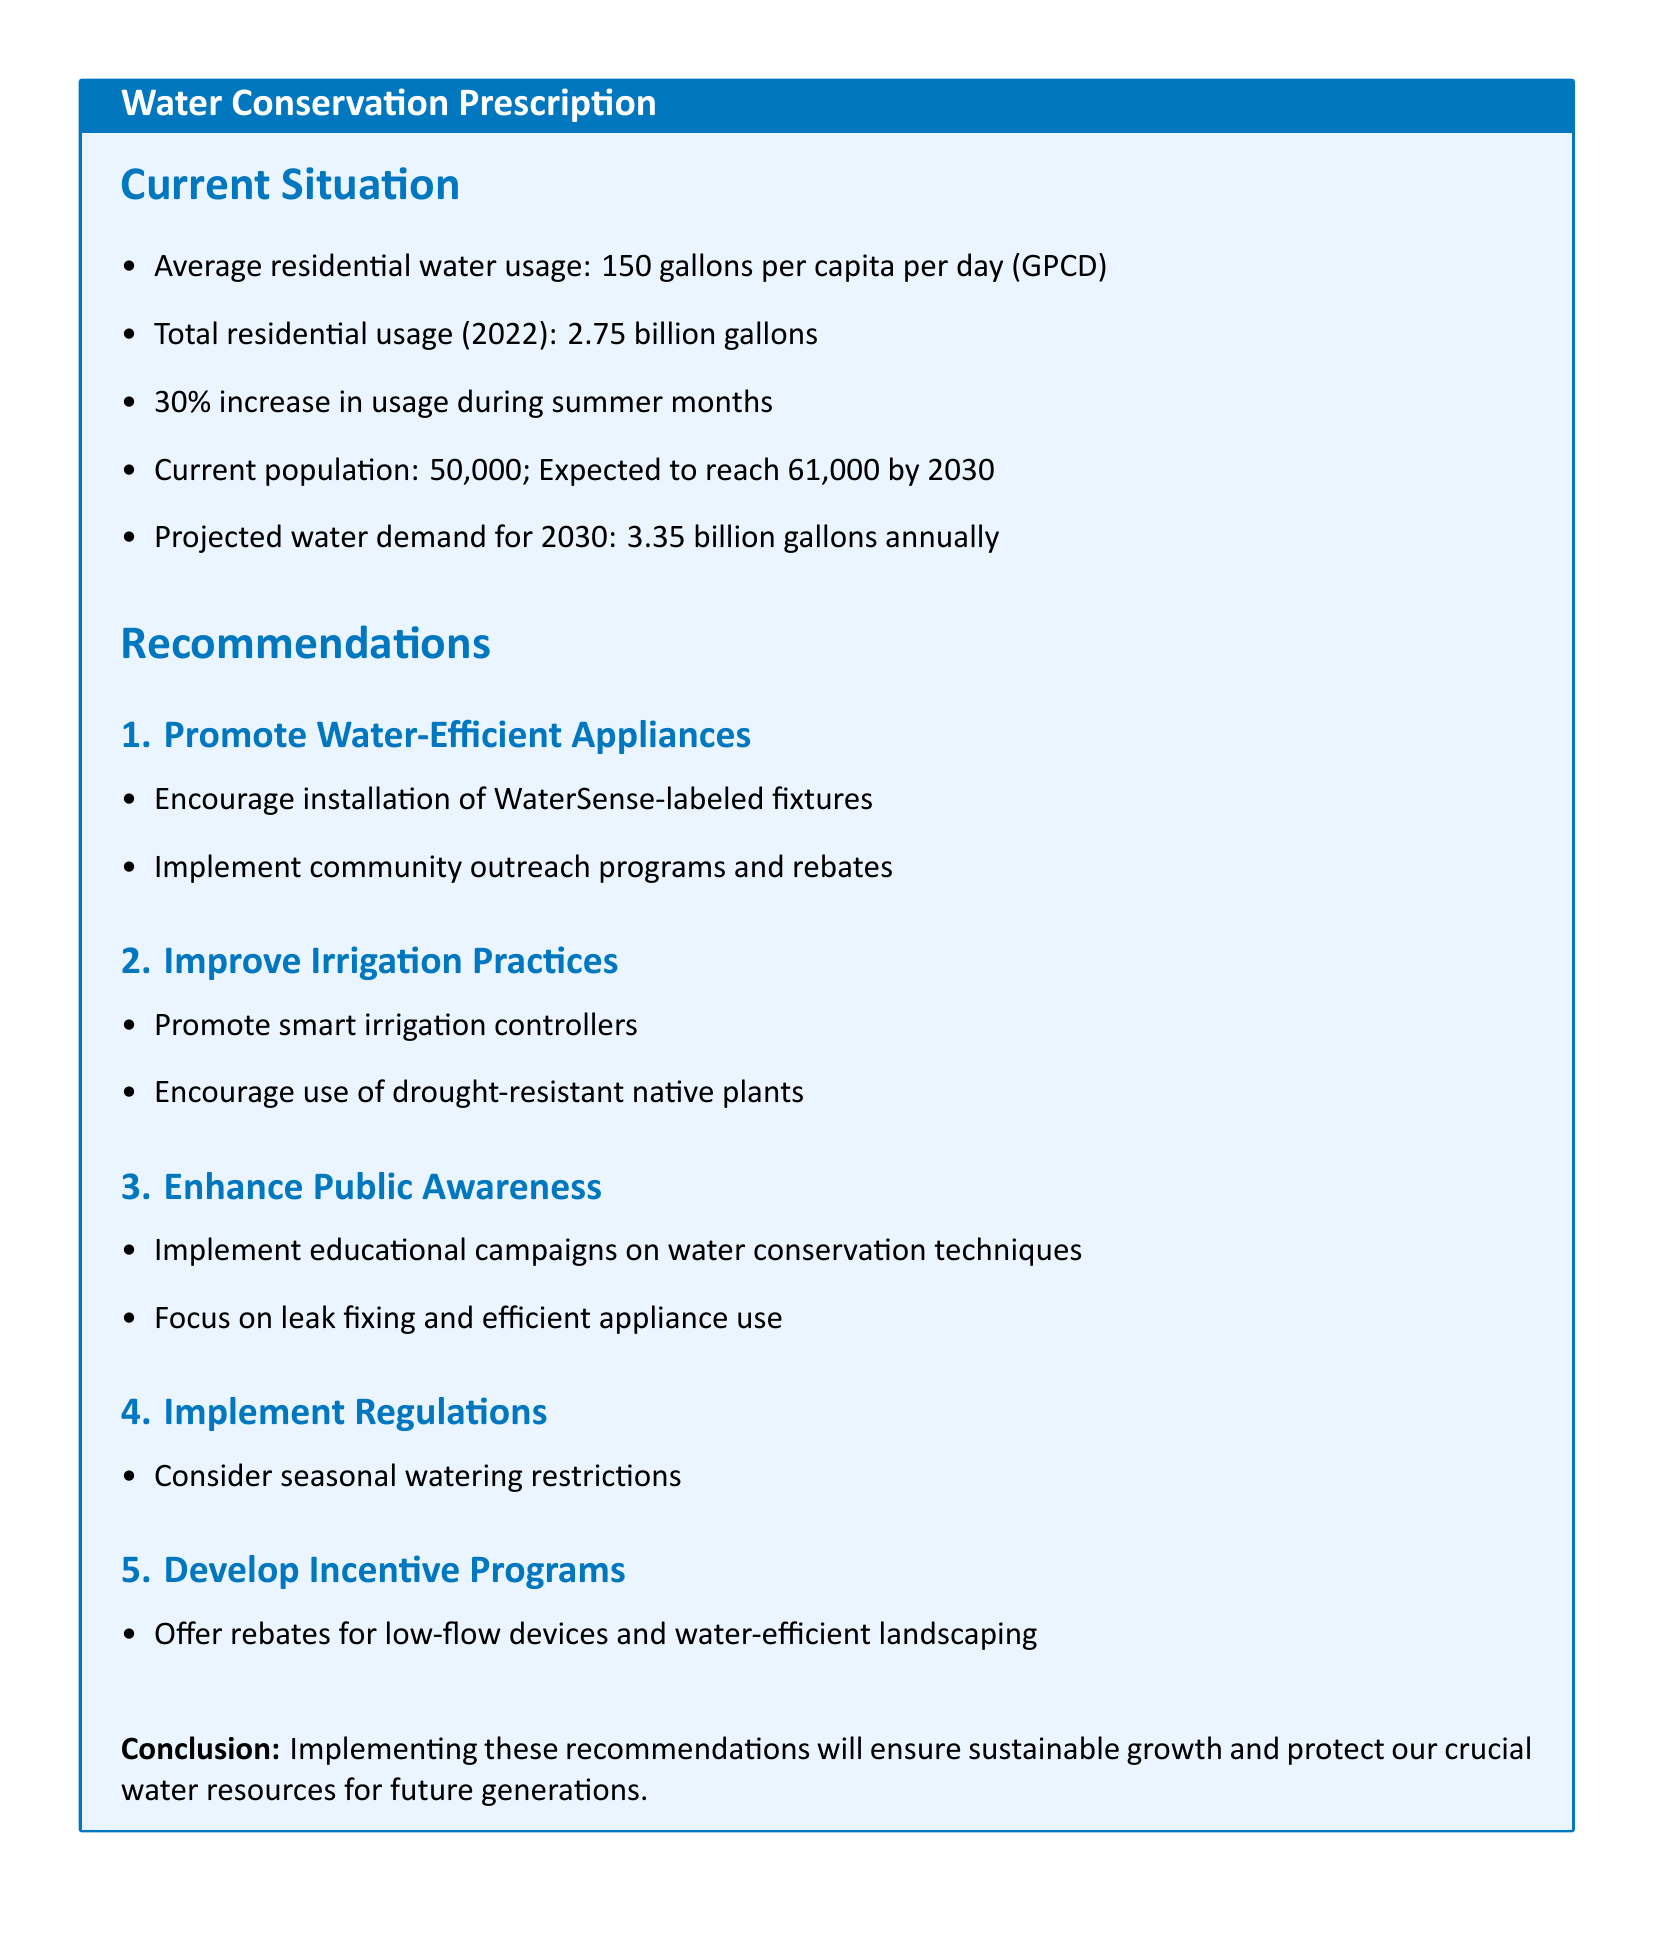What is the average residential water usage? The document states the average residential water usage is 150 gallons per capita per day.
Answer: 150 gallons per capita per day What was the total residential water usage in 2022? The total residential water usage for the year 2022 is provided in the document as 2.75 billion gallons.
Answer: 2.75 billion gallons What is the projected water demand for 2030? The projected water demand for the year 2030 is mentioned as 3.35 billion gallons annually.
Answer: 3.35 billion gallons annually What percentage increase in water usage occurs during summer months? The document specifies a 30% increase in usage during the summer months.
Answer: 30% What is the current population? The document states the current population is 50,000.
Answer: 50,000 What is one recommendation for improving irrigation practices? The document suggests promoting smart irrigation controllers as a recommendation for improving irrigation practices.
Answer: Promote smart irrigation controllers What is the focus area of the educational campaigns? The document indicates that the educational campaigns will focus on water conservation techniques and leak fixing.
Answer: Water conservation techniques and leak fixing What type of devices should be considered for rebates? The document mentions offering rebates for low-flow devices and water-efficient landscaping.
Answer: Low-flow devices and water-efficient landscaping What is the intention behind implementing seasonal watering restrictions? The document considers implementing seasonal watering restrictions as part of its regulatory recommendations.
Answer: Regulatory recommendations 